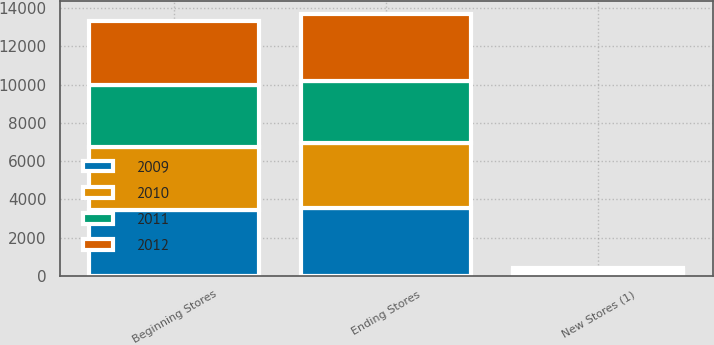<chart> <loc_0><loc_0><loc_500><loc_500><stacked_bar_chart><ecel><fcel>Beginning Stores<fcel>New Stores (1)<fcel>Ending Stores<nl><fcel>2009<fcel>3460<fcel>116<fcel>3576<nl><fcel>2012<fcel>3369<fcel>95<fcel>3460<nl><fcel>2010<fcel>3264<fcel>110<fcel>3369<nl><fcel>2011<fcel>3243<fcel>75<fcel>3264<nl></chart> 